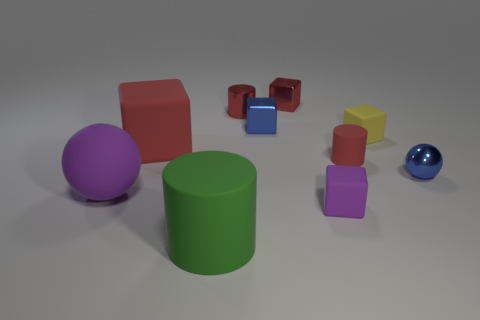Do the purple cube and the green cylinder have the same size?
Offer a very short reply. No. Is the shape of the purple matte thing left of the metallic cylinder the same as the tiny rubber object behind the big cube?
Your answer should be compact. No. There is a yellow thing that is the same shape as the small purple thing; what is its material?
Provide a succinct answer. Rubber. The small metal thing that is to the right of the tiny matte cube that is in front of the blue shiny sphere is what shape?
Your response must be concise. Sphere. Do the cylinder in front of the blue metal ball and the tiny red cube have the same material?
Make the answer very short. No. Are there an equal number of large red rubber blocks in front of the big purple sphere and shiny spheres that are in front of the tiny metal sphere?
Provide a succinct answer. Yes. What is the material of the small thing that is the same color as the big sphere?
Your answer should be very brief. Rubber. What number of purple rubber blocks are on the right side of the blue metallic object that is on the left side of the small red block?
Make the answer very short. 1. There is a matte cylinder that is behind the green cylinder; does it have the same color as the large object that is behind the small red matte cylinder?
Keep it short and to the point. Yes. What material is the yellow object that is the same size as the blue ball?
Your answer should be very brief. Rubber. 